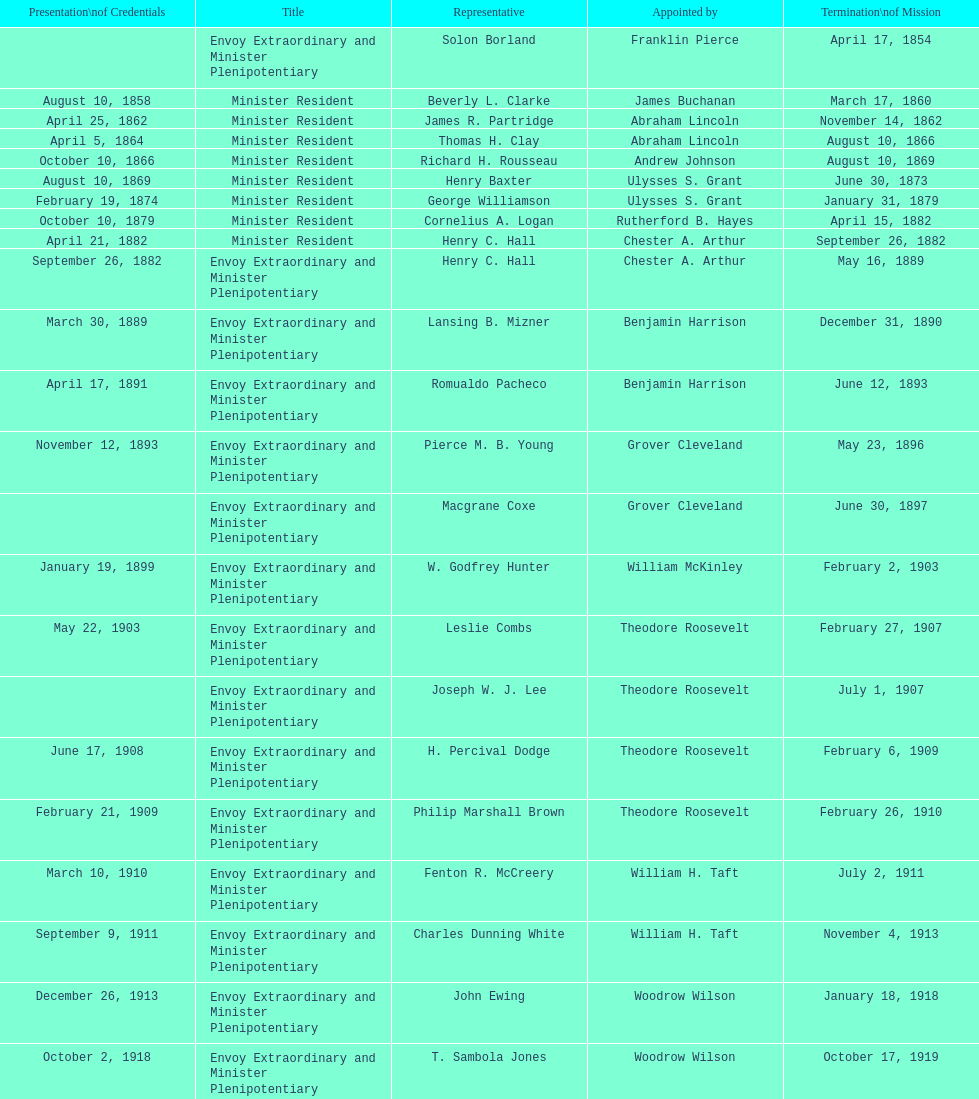Can you parse all the data within this table? {'header': ['Presentation\\nof Credentials', 'Title', 'Representative', 'Appointed by', 'Termination\\nof Mission'], 'rows': [['', 'Envoy Extraordinary and Minister Plenipotentiary', 'Solon Borland', 'Franklin Pierce', 'April 17, 1854'], ['August 10, 1858', 'Minister Resident', 'Beverly L. Clarke', 'James Buchanan', 'March 17, 1860'], ['April 25, 1862', 'Minister Resident', 'James R. Partridge', 'Abraham Lincoln', 'November 14, 1862'], ['April 5, 1864', 'Minister Resident', 'Thomas H. Clay', 'Abraham Lincoln', 'August 10, 1866'], ['October 10, 1866', 'Minister Resident', 'Richard H. Rousseau', 'Andrew Johnson', 'August 10, 1869'], ['August 10, 1869', 'Minister Resident', 'Henry Baxter', 'Ulysses S. Grant', 'June 30, 1873'], ['February 19, 1874', 'Minister Resident', 'George Williamson', 'Ulysses S. Grant', 'January 31, 1879'], ['October 10, 1879', 'Minister Resident', 'Cornelius A. Logan', 'Rutherford B. Hayes', 'April 15, 1882'], ['April 21, 1882', 'Minister Resident', 'Henry C. Hall', 'Chester A. Arthur', 'September 26, 1882'], ['September 26, 1882', 'Envoy Extraordinary and Minister Plenipotentiary', 'Henry C. Hall', 'Chester A. Arthur', 'May 16, 1889'], ['March 30, 1889', 'Envoy Extraordinary and Minister Plenipotentiary', 'Lansing B. Mizner', 'Benjamin Harrison', 'December 31, 1890'], ['April 17, 1891', 'Envoy Extraordinary and Minister Plenipotentiary', 'Romualdo Pacheco', 'Benjamin Harrison', 'June 12, 1893'], ['November 12, 1893', 'Envoy Extraordinary and Minister Plenipotentiary', 'Pierce M. B. Young', 'Grover Cleveland', 'May 23, 1896'], ['', 'Envoy Extraordinary and Minister Plenipotentiary', 'Macgrane Coxe', 'Grover Cleveland', 'June 30, 1897'], ['January 19, 1899', 'Envoy Extraordinary and Minister Plenipotentiary', 'W. Godfrey Hunter', 'William McKinley', 'February 2, 1903'], ['May 22, 1903', 'Envoy Extraordinary and Minister Plenipotentiary', 'Leslie Combs', 'Theodore Roosevelt', 'February 27, 1907'], ['', 'Envoy Extraordinary and Minister Plenipotentiary', 'Joseph W. J. Lee', 'Theodore Roosevelt', 'July 1, 1907'], ['June 17, 1908', 'Envoy Extraordinary and Minister Plenipotentiary', 'H. Percival Dodge', 'Theodore Roosevelt', 'February 6, 1909'], ['February 21, 1909', 'Envoy Extraordinary and Minister Plenipotentiary', 'Philip Marshall Brown', 'Theodore Roosevelt', 'February 26, 1910'], ['March 10, 1910', 'Envoy Extraordinary and Minister Plenipotentiary', 'Fenton R. McCreery', 'William H. Taft', 'July 2, 1911'], ['September 9, 1911', 'Envoy Extraordinary and Minister Plenipotentiary', 'Charles Dunning White', 'William H. Taft', 'November 4, 1913'], ['December 26, 1913', 'Envoy Extraordinary and Minister Plenipotentiary', 'John Ewing', 'Woodrow Wilson', 'January 18, 1918'], ['October 2, 1918', 'Envoy Extraordinary and Minister Plenipotentiary', 'T. Sambola Jones', 'Woodrow Wilson', 'October 17, 1919'], ['January 18, 1922', 'Envoy Extraordinary and Minister Plenipotentiary', 'Franklin E. Morales', 'Warren G. Harding', 'March 2, 1925'], ['November 21, 1925', 'Envoy Extraordinary and Minister Plenipotentiary', 'George T. Summerlin', 'Calvin Coolidge', 'December 17, 1929'], ['May 31, 1930', 'Envoy Extraordinary and Minister Plenipotentiary', 'Julius G. Lay', 'Herbert Hoover', 'March 17, 1935'], ['July 19, 1935', 'Envoy Extraordinary and Minister Plenipotentiary', 'Leo J. Keena', 'Franklin D. Roosevelt', 'May 1, 1937'], ['September 8, 1937', 'Envoy Extraordinary and Minister Plenipotentiary', 'John Draper Erwin', 'Franklin D. Roosevelt', 'April 27, 1943'], ['April 27, 1943', 'Ambassador Extraordinary and Plenipotentiary', 'John Draper Erwin', 'Franklin D. Roosevelt', 'April 16, 1947'], ['June 23, 1947', 'Ambassador Extraordinary and Plenipotentiary', 'Paul C. Daniels', 'Harry S. Truman', 'October 30, 1947'], ['May 15, 1948', 'Ambassador Extraordinary and Plenipotentiary', 'Herbert S. Bursley', 'Harry S. Truman', 'December 12, 1950'], ['March 14, 1951', 'Ambassador Extraordinary and Plenipotentiary', 'John Draper Erwin', 'Harry S. Truman', 'February 28, 1954'], ['March 5, 1954', 'Ambassador Extraordinary and Plenipotentiary', 'Whiting Willauer', 'Dwight D. Eisenhower', 'March 24, 1958'], ['April 30, 1958', 'Ambassador Extraordinary and Plenipotentiary', 'Robert Newbegin', 'Dwight D. Eisenhower', 'August 3, 1960'], ['November 3, 1960', 'Ambassador Extraordinary and Plenipotentiary', 'Charles R. Burrows', 'Dwight D. Eisenhower', 'June 28, 1965'], ['July 12, 1965', 'Ambassador Extraordinary and Plenipotentiary', 'Joseph J. Jova', 'Lyndon B. Johnson', 'June 21, 1969'], ['November 5, 1969', 'Ambassador Extraordinary and Plenipotentiary', 'Hewson A. Ryan', 'Richard Nixon', 'May 30, 1973'], ['June 15, 1973', 'Ambassador Extraordinary and Plenipotentiary', 'Phillip V. Sanchez', 'Richard Nixon', 'July 17, 1976'], ['October 27, 1976', 'Ambassador Extraordinary and Plenipotentiary', 'Ralph E. Becker', 'Gerald Ford', 'August 1, 1977'], ['October 27, 1977', 'Ambassador Extraordinary and Plenipotentiary', 'Mari-Luci Jaramillo', 'Jimmy Carter', 'September 19, 1980'], ['October 10, 1980', 'Ambassador Extraordinary and Plenipotentiary', 'Jack R. Binns', 'Jimmy Carter', 'October 31, 1981'], ['November 11, 1981', 'Ambassador Extraordinary and Plenipotentiary', 'John D. Negroponte', 'Ronald Reagan', 'May 30, 1985'], ['August 22, 1985', 'Ambassador Extraordinary and Plenipotentiary', 'John Arthur Ferch', 'Ronald Reagan', 'July 9, 1986'], ['November 4, 1986', 'Ambassador Extraordinary and Plenipotentiary', 'Everett Ellis Briggs', 'Ronald Reagan', 'June 15, 1989'], ['January 29, 1990', 'Ambassador Extraordinary and Plenipotentiary', 'Cresencio S. Arcos, Jr.', 'George H. W. Bush', 'July 1, 1993'], ['July 21, 1993', 'Ambassador Extraordinary and Plenipotentiary', 'William Thornton Pryce', 'Bill Clinton', 'August 15, 1996'], ['August 29, 1996', 'Ambassador Extraordinary and Plenipotentiary', 'James F. Creagan', 'Bill Clinton', 'July 20, 1999'], ['August 25, 1999', 'Ambassador Extraordinary and Plenipotentiary', 'Frank Almaguer', 'Bill Clinton', 'September 5, 2002'], ['October 8, 2002', 'Ambassador Extraordinary and Plenipotentiary', 'Larry Leon Palmer', 'George W. Bush', 'May 7, 2005'], ['November 8, 2005', 'Ambassador Extraordinary and Plenipotentiary', 'Charles A. Ford', 'George W. Bush', 'ca. April 2008'], ['September 19, 2008', 'Ambassador Extraordinary and Plenipotentiary', 'Hugo Llorens', 'George W. Bush', 'ca. July 2011'], ['July 26, 2011', 'Ambassador Extraordinary and Plenipotentiary', 'Lisa Kubiske', 'Barack Obama', 'Incumbent']]} What was the number of representatives appointed by theodore roosevelt? 4. 